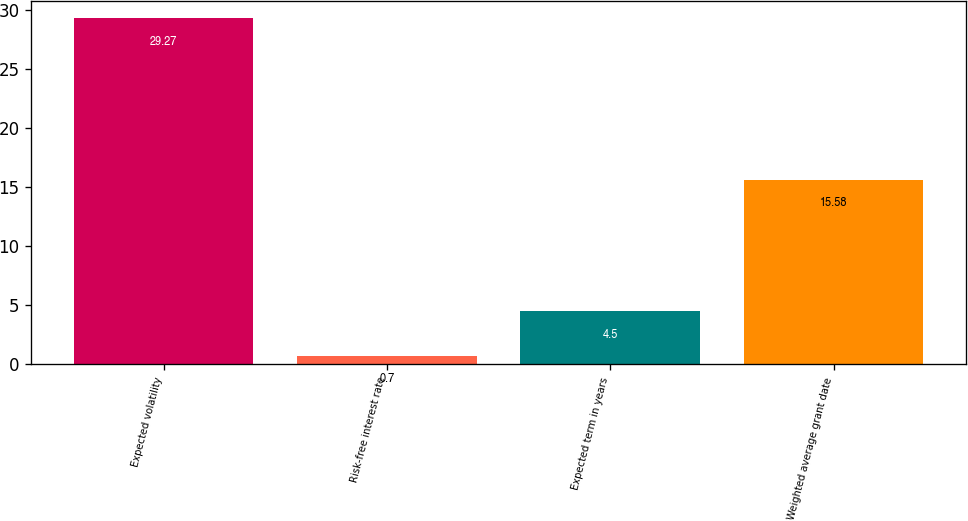Convert chart to OTSL. <chart><loc_0><loc_0><loc_500><loc_500><bar_chart><fcel>Expected volatility<fcel>Risk-free interest rate<fcel>Expected term in years<fcel>Weighted average grant date<nl><fcel>29.27<fcel>0.7<fcel>4.5<fcel>15.58<nl></chart> 